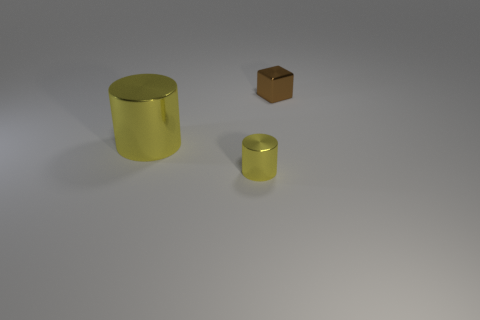Add 1 cylinders. How many objects exist? 4 Subtract all cubes. How many objects are left? 2 Subtract 1 blocks. How many blocks are left? 0 Add 3 small brown metal cubes. How many small brown metal cubes exist? 4 Subtract 0 blue spheres. How many objects are left? 3 Subtract all green cylinders. Subtract all yellow spheres. How many cylinders are left? 2 Subtract all yellow things. Subtract all small shiny cylinders. How many objects are left? 0 Add 3 yellow metal things. How many yellow metal things are left? 5 